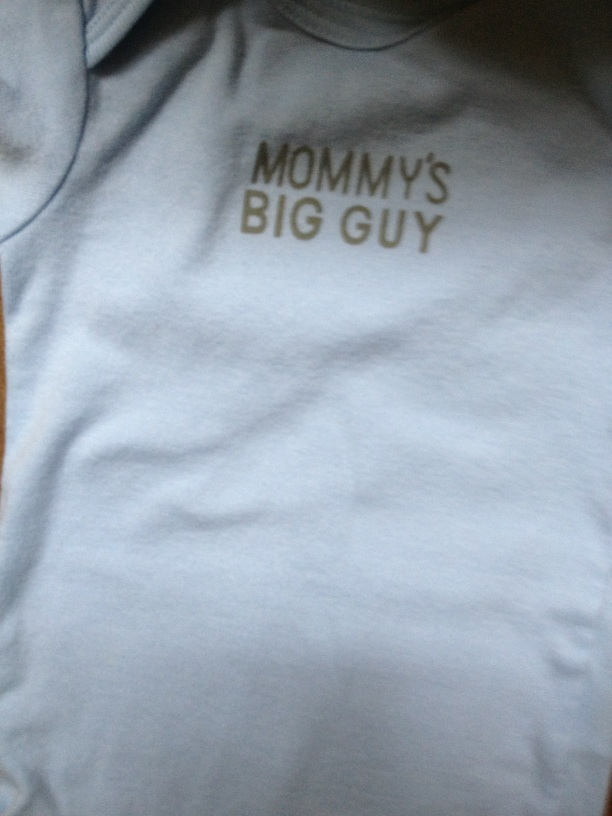What is on this baby's shirt? The text on the baby's shirt reads 'Mommy's Big Guy.' 